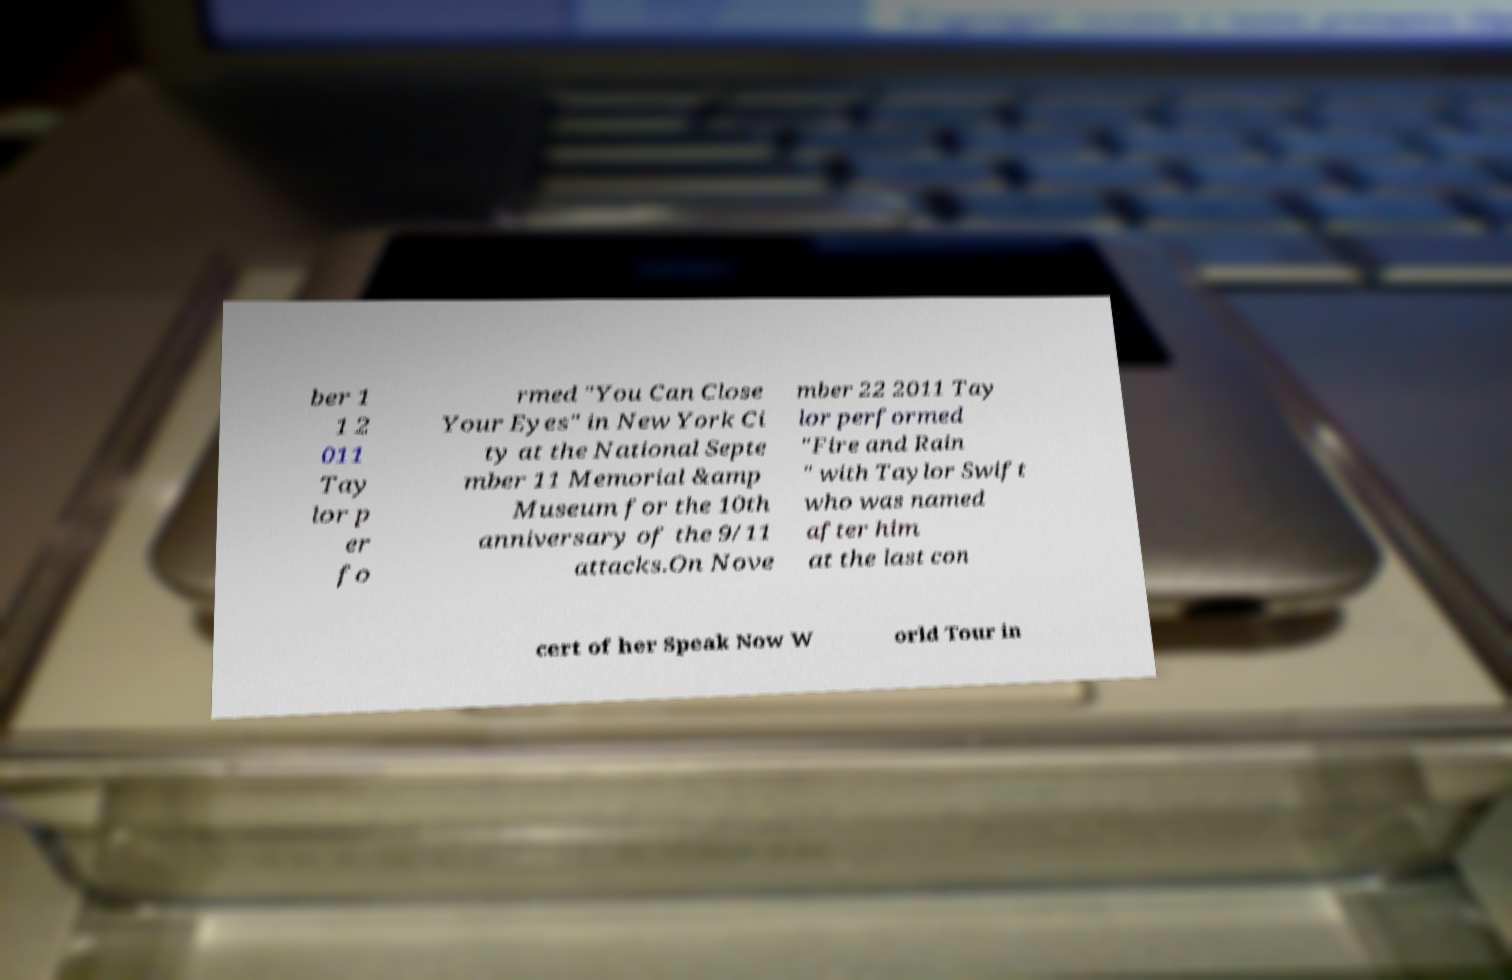Can you read and provide the text displayed in the image?This photo seems to have some interesting text. Can you extract and type it out for me? ber 1 1 2 011 Tay lor p er fo rmed "You Can Close Your Eyes" in New York Ci ty at the National Septe mber 11 Memorial &amp Museum for the 10th anniversary of the 9/11 attacks.On Nove mber 22 2011 Tay lor performed "Fire and Rain " with Taylor Swift who was named after him at the last con cert of her Speak Now W orld Tour in 